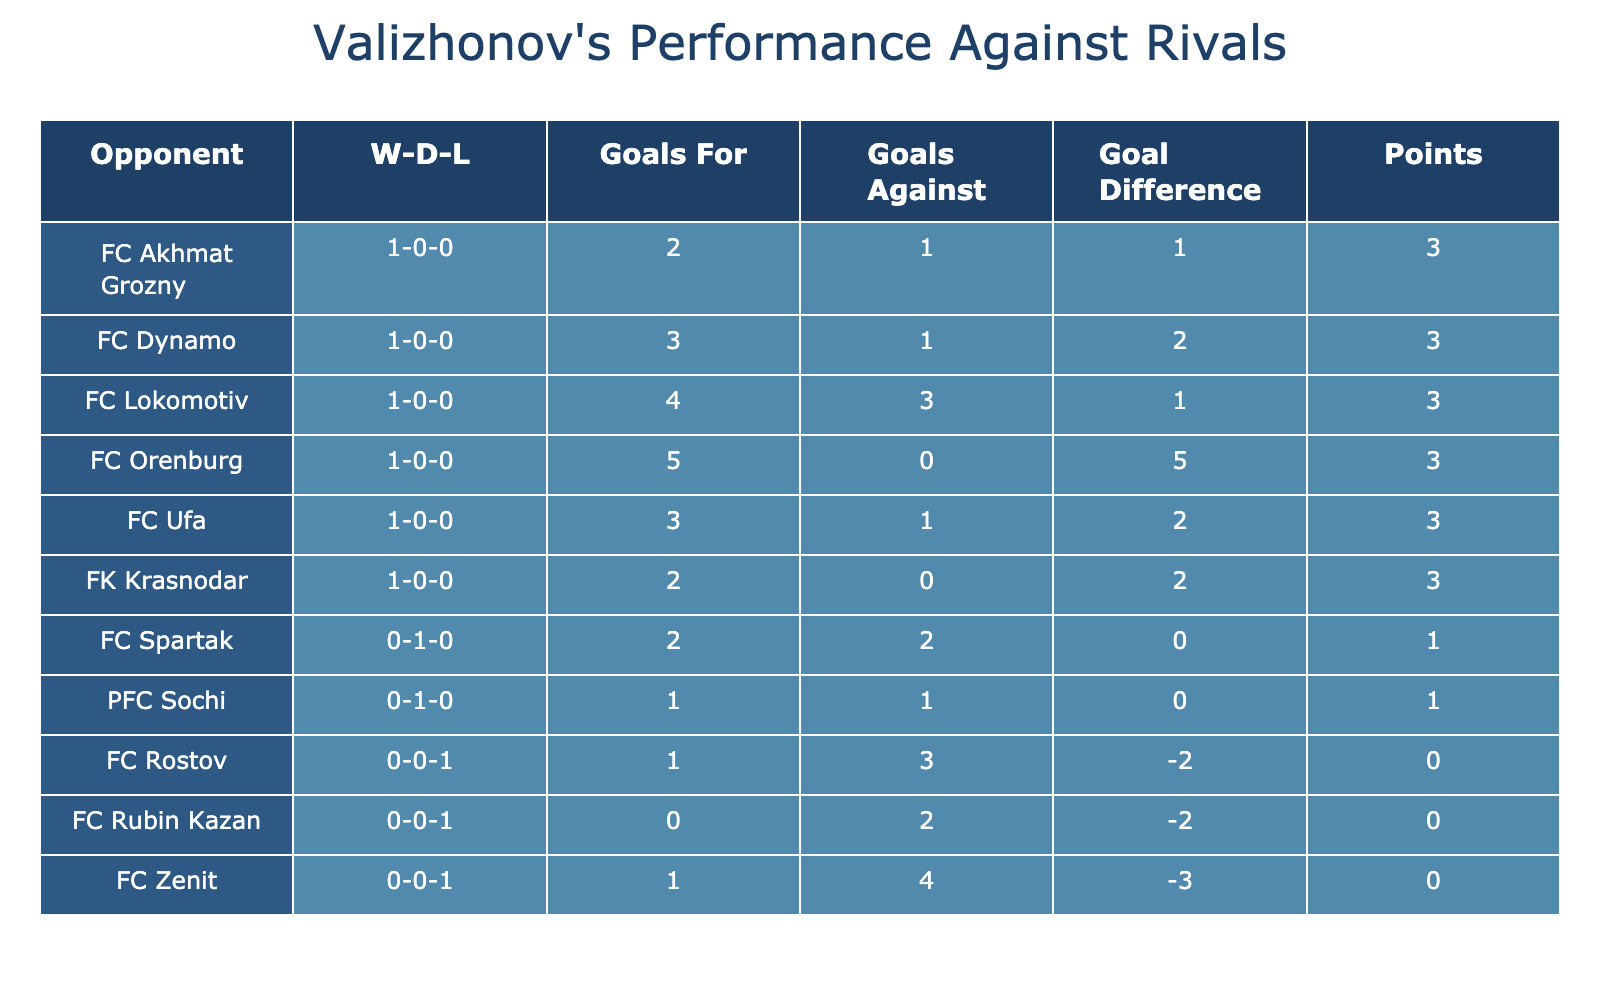What was the result of Valizhonov's match against FC Dynamo? The table shows that Valizhonov played FC Dynamo on March 15, 2021, at home and won the match.
Answer: Win How many goals did Valizhonov score against FC Ufa? According to the table, Valizhonov scored 3 goals in the match against FC Ufa on September 18, 2022.
Answer: 3 Did Valizhonov have a higher total of goals scored or conceded? To find this, we sum the goals scored (3+2+1+2+4+0+1+3+2+5 = 23) and the goals conceded (1+2+4+0+3+2+1+1+3+0 = 18). Since 23 is greater than 18, the answer is yes.
Answer: Yes What is Valizhonov's overall win-draw-loss record against FC Akhmat Grozny? Looking at the table, Valizhonov's record against FC Akhmat Grozny shows 1 win, 0 draws, and 0 losses, thus the overall record is 1-0-0.
Answer: 1-0-0 What was Valizhonov's points total from matches against FK Krasnodar and FC Lokomotiv combined? FK Krasnodar resulted in a win, earning 3 points, and FC Lokomotiv also resulted in a win, earning another 3 points. Therefore, combining them gives 3 + 3 = 6 points.
Answer: 6 Against which opponent did Valizhonov achieve the highest goals scored in a single match? By looking at the table, the highest number of goals scored in a single match was 5 against FC Orenburg on June 15, 2023.
Answer: FC Orenburg How many matches did Valizhonov play at home versus away in total? Counting the entries in the table, there were 5 home matches (against FC Dynamo, FC Zenit, FC Lokomotiv, FC Ufa, FC Akhmat Grozny, and FC Orenburg) and 5 away matches (against FC Spartak, FK Krasnodar, FC Rubin Kazan, FC Rostov). Thus, the total is 10 matches played.
Answer: 10 Which opponent had a better goal difference when playing against Valizhonov? From the results, FC Zenit had a goal difference of -3 (1 scored - 4 conceded), while others such as FC Ufa had a +2 (3 scored - 1 conceded). Hence the best goal difference against Valizhonov is with FC Ufa with +2.
Answer: FC Ufa Was there any match where Valizhonov conceded zero goals? Upon examining the table, it can be seen that Valizhonov did not concede any goals in the match against FC Orenburg. Therefore, the answer is yes.
Answer: Yes 